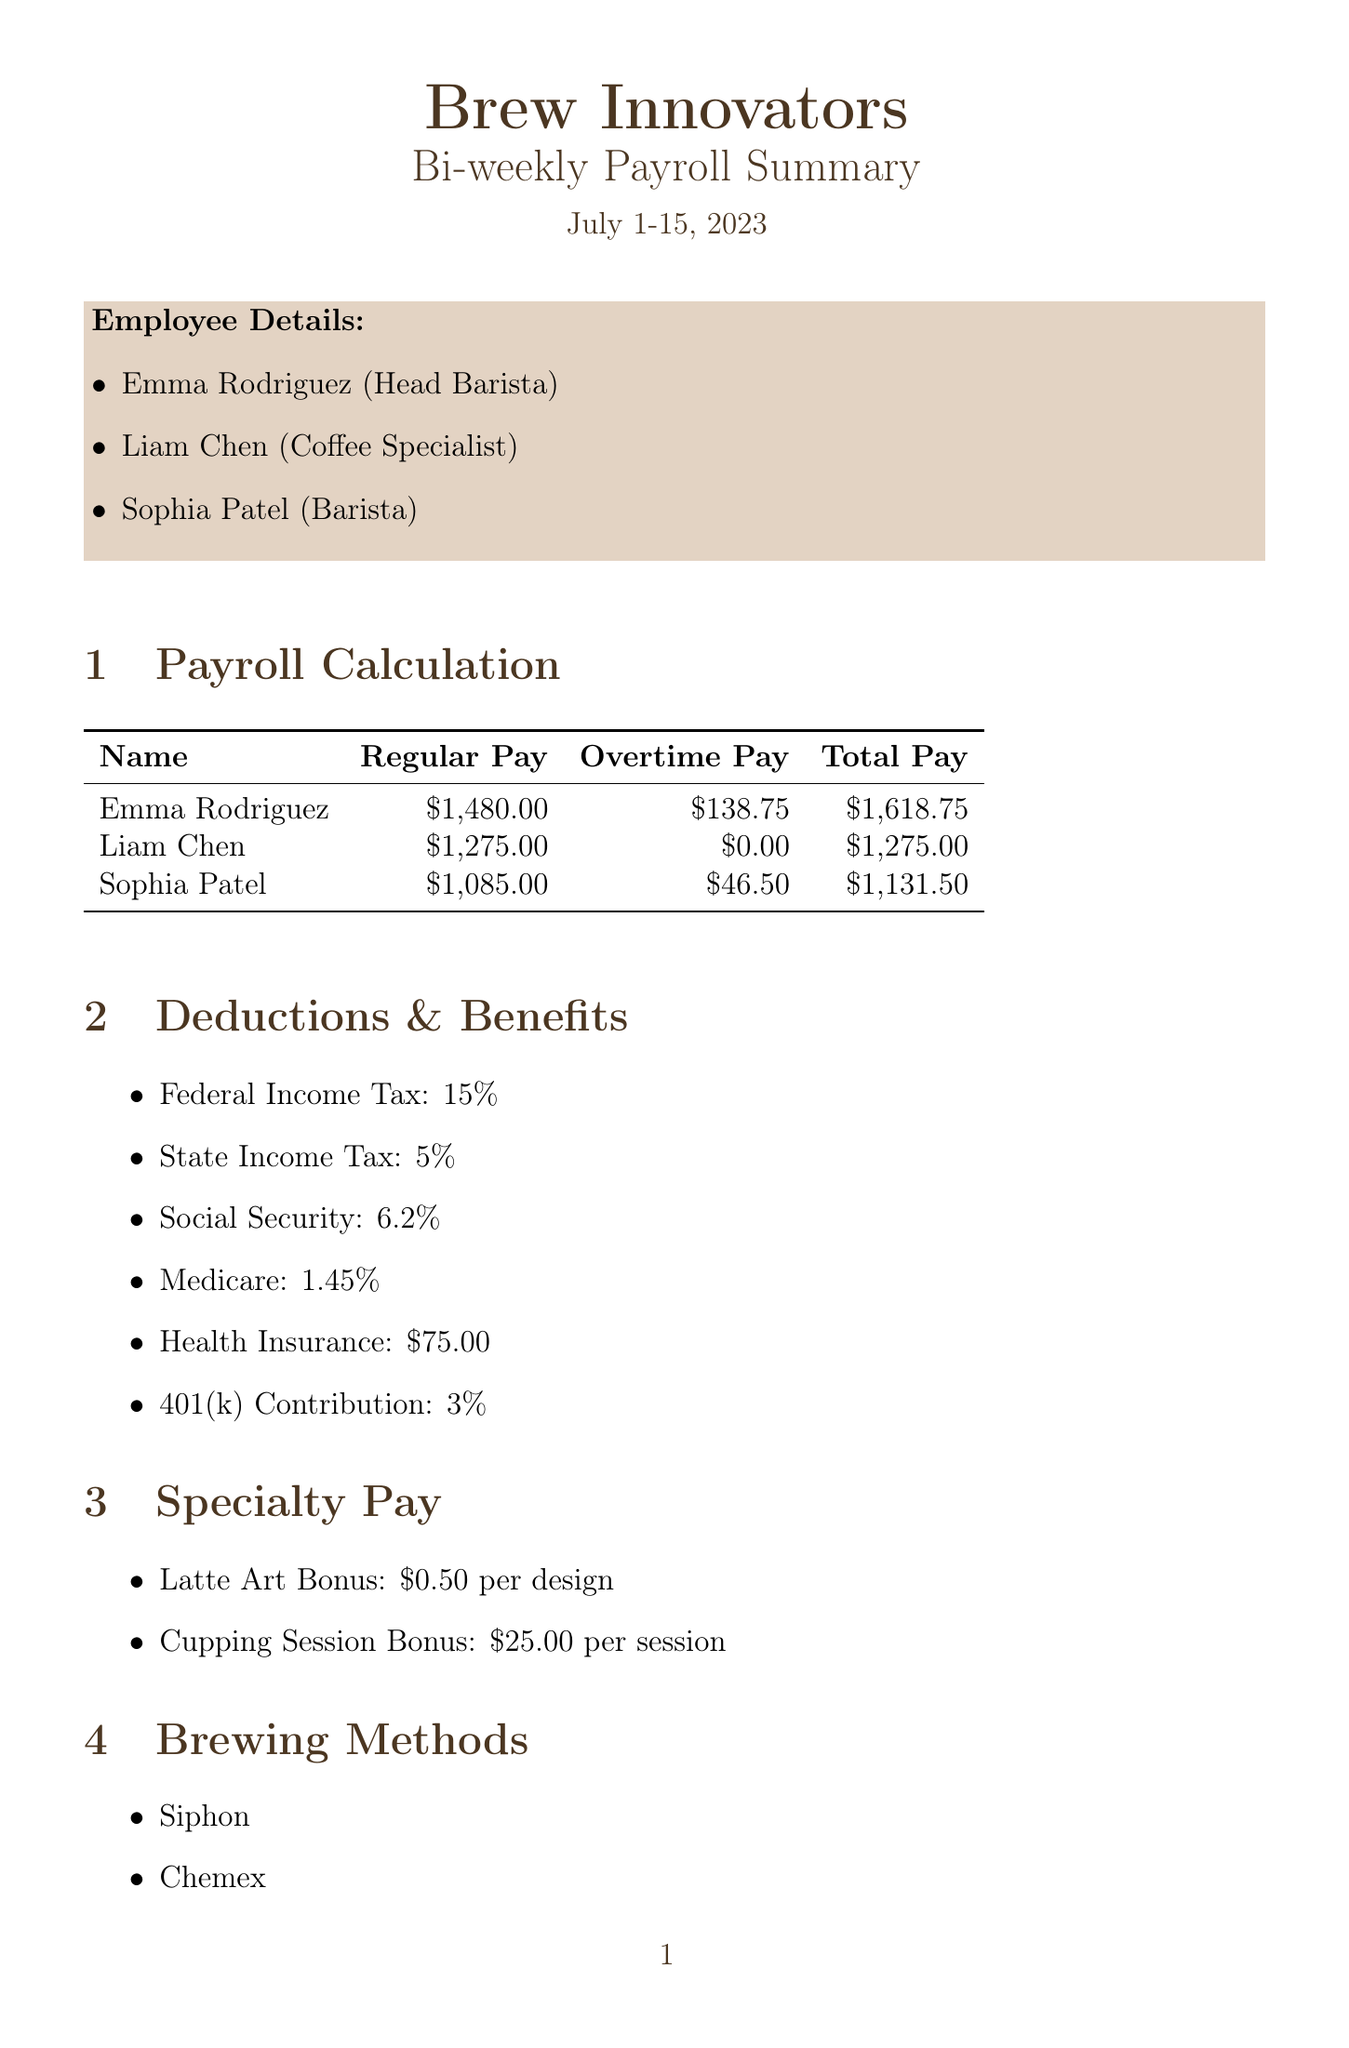What is the company name? The company name is indicated at the top of the document.
Answer: Brew Innovators What is the payroll period? The payroll period is specifically mentioned beneath the title of the document.
Answer: July 1-15, 2023 How many regular hours did Emma Rodriguez work? Regular hours for each employee are listed in the employee details section.
Answer: 80 What is the overtime pay for Liam Chen? Overtime pay for each employee is calculated and presented in the payroll calculation section.
Answer: $0.00 What is the health insurance deduction amount? The amount for health insurance is mentioned in the deductions and benefits section.
Answer: $75.00 What bonus is associated with cupping sessions? The specialty pay section specifies the bonus related to cupping sessions.
Answer: $25.00 How many hours of training were conducted on Advanced Espresso Techniques? The training sessions section details the duration of each training session.
Answer: 2 What is the total tips pool amount? The tips distribution section provides the total tips pool amount.
Answer: $850.00 Which brewing method is mentioned first? The brewing methods section lists various methods, the first one can be identified there.
Answer: Siphon 